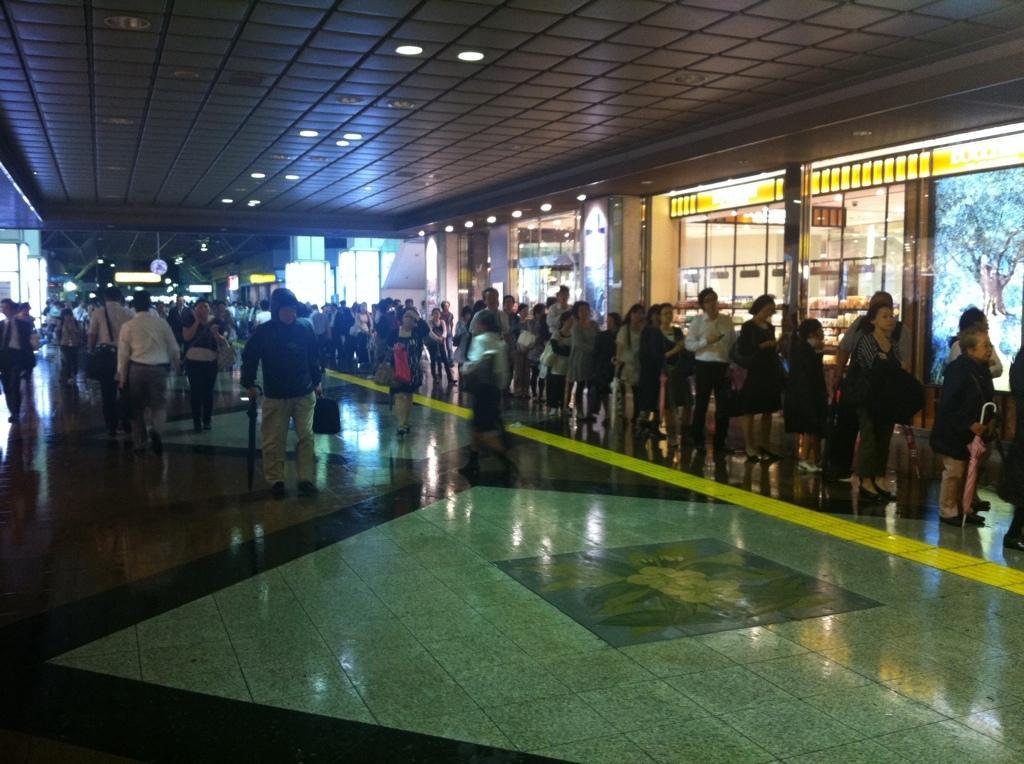How would you summarize this image in a sentence or two? At the top we can see the ceiling and the lights. In this picture we can see the boards, people are standing in the queue. On the left side of the picture we can see the people walking on the floor. We can see the objects in this picture. 